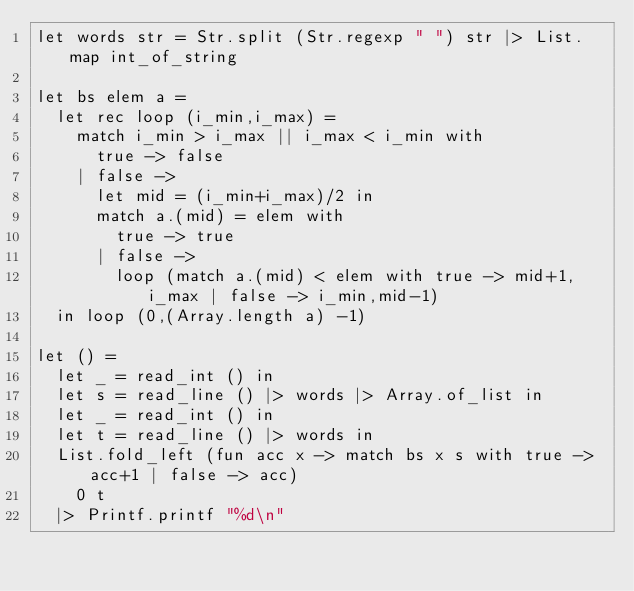Convert code to text. <code><loc_0><loc_0><loc_500><loc_500><_OCaml_>let words str = Str.split (Str.regexp " ") str |> List.map int_of_string

let bs elem a =
  let rec loop (i_min,i_max) =
    match i_min > i_max || i_max < i_min with
      true -> false
    | false ->
      let mid = (i_min+i_max)/2 in
      match a.(mid) = elem with
        true -> true
      | false ->
        loop (match a.(mid) < elem with true -> mid+1,i_max | false -> i_min,mid-1)
  in loop (0,(Array.length a) -1)

let () =
  let _ = read_int () in
  let s = read_line () |> words |> Array.of_list in
  let _ = read_int () in
  let t = read_line () |> words in
  List.fold_left (fun acc x -> match bs x s with true -> acc+1 | false -> acc)
    0 t
  |> Printf.printf "%d\n"</code> 